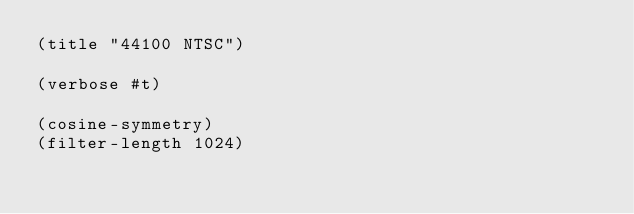<code> <loc_0><loc_0><loc_500><loc_500><_Scheme_>(title "44100 NTSC")

(verbose #t)

(cosine-symmetry)
(filter-length 1024)</code> 